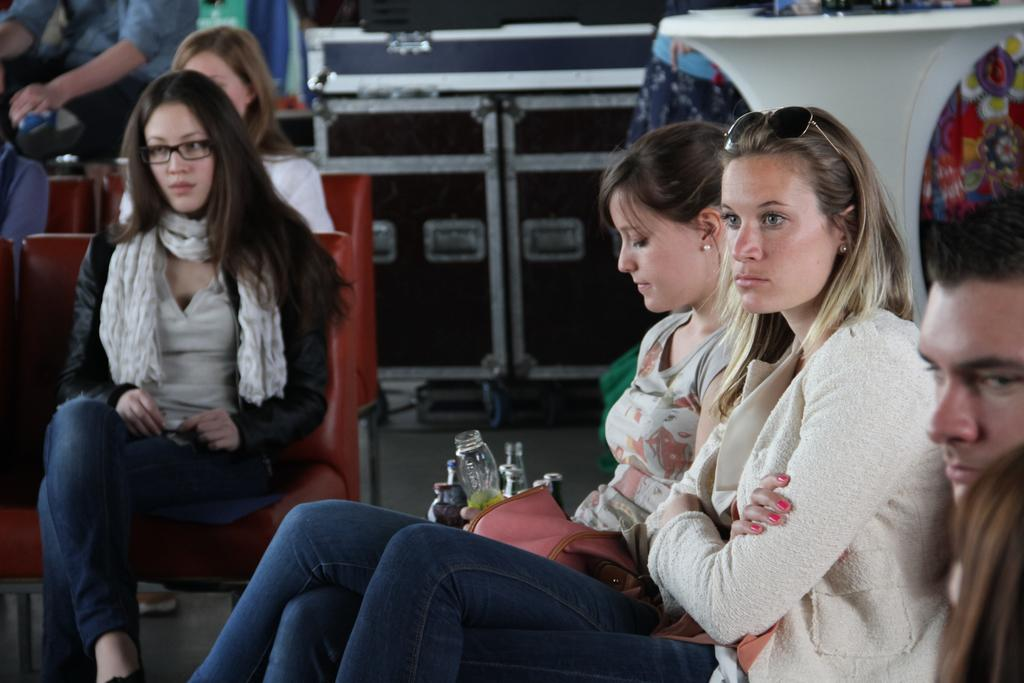Who or what can be seen in the image? There are people in the image. What are the people sitting on in the image? There are chairs in the image. What can be seen on the stand in the image? There are bottles on the stand in the image. Can you describe the other objects in the image? There are some other objects in the image, but their specific details are not mentioned in the provided facts. What type of skin condition can be seen on the people in the image? There is no mention of any skin condition in the image, and therefore it cannot be determined from the provided facts. 